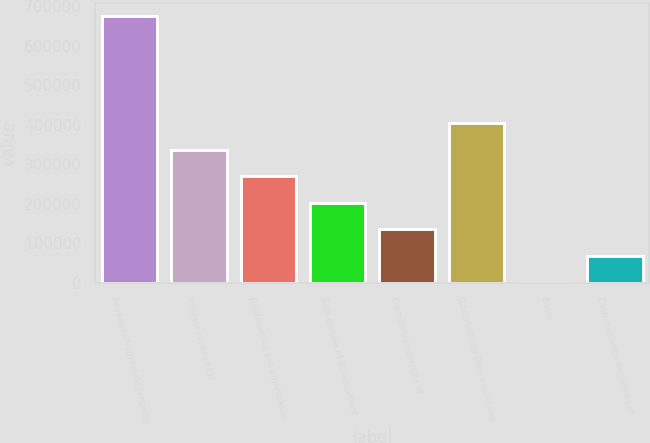Convert chart. <chart><loc_0><loc_0><loc_500><loc_500><bar_chart><fcel>Revenues from rental property<fcel>Interest expense (3)<fcel>Depreciation and amortization<fcel>Gain on sale of development<fcel>Gain on transfer/sale of<fcel>(Loss)/income from continuing<fcel>Basic<fcel>Cash dividends declared per<nl><fcel>674534<fcel>337268<fcel>269814<fcel>202361<fcel>134908<fcel>404721<fcel>1.35<fcel>67454.6<nl></chart> 